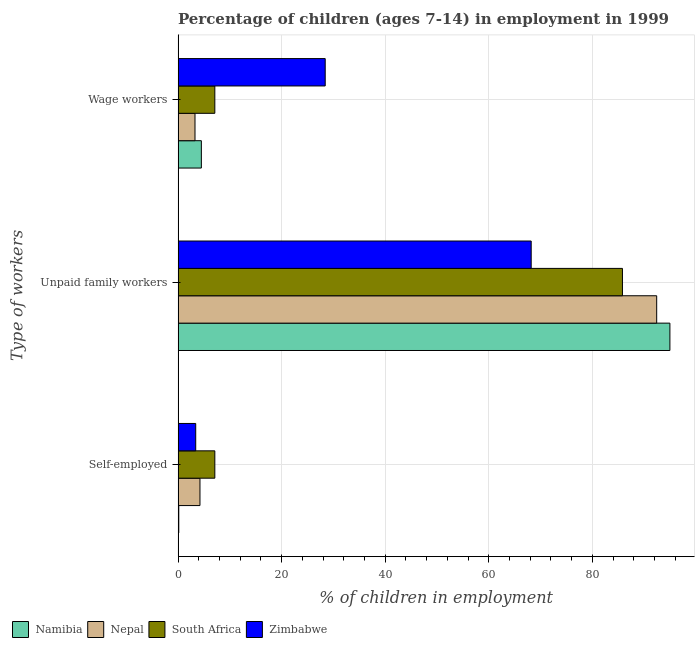How many different coloured bars are there?
Your answer should be compact. 4. Are the number of bars per tick equal to the number of legend labels?
Offer a very short reply. Yes. What is the label of the 1st group of bars from the top?
Make the answer very short. Wage workers. What is the percentage of children employed as unpaid family workers in Nepal?
Keep it short and to the point. 92.41. Across all countries, what is the maximum percentage of children employed as unpaid family workers?
Provide a succinct answer. 94.96. Across all countries, what is the minimum percentage of self employed children?
Keep it short and to the point. 0.14. In which country was the percentage of children employed as unpaid family workers maximum?
Offer a terse response. Namibia. In which country was the percentage of children employed as wage workers minimum?
Make the answer very short. Nepal. What is the total percentage of self employed children in the graph?
Your answer should be compact. 14.88. What is the difference between the percentage of children employed as wage workers in South Africa and that in Namibia?
Provide a short and direct response. 2.6. What is the difference between the percentage of self employed children in Nepal and the percentage of children employed as wage workers in South Africa?
Offer a terse response. -2.87. What is the average percentage of children employed as wage workers per country?
Make the answer very short. 10.82. What is the difference between the percentage of self employed children and percentage of children employed as unpaid family workers in Nepal?
Ensure brevity in your answer.  -88.18. In how many countries, is the percentage of children employed as unpaid family workers greater than 68 %?
Your response must be concise. 4. What is the ratio of the percentage of children employed as wage workers in Nepal to that in Namibia?
Offer a very short reply. 0.73. Is the percentage of children employed as wage workers in Nepal less than that in Namibia?
Give a very brief answer. Yes. Is the difference between the percentage of children employed as wage workers in Nepal and Namibia greater than the difference between the percentage of self employed children in Nepal and Namibia?
Offer a terse response. No. What is the difference between the highest and the second highest percentage of children employed as wage workers?
Make the answer very short. 21.31. What is the difference between the highest and the lowest percentage of children employed as unpaid family workers?
Provide a short and direct response. 26.78. Is the sum of the percentage of children employed as wage workers in Zimbabwe and Namibia greater than the maximum percentage of children employed as unpaid family workers across all countries?
Your answer should be very brief. No. What does the 4th bar from the top in Self-employed represents?
Offer a very short reply. Namibia. What does the 4th bar from the bottom in Self-employed represents?
Provide a succinct answer. Zimbabwe. Are the values on the major ticks of X-axis written in scientific E-notation?
Your answer should be very brief. No. How many legend labels are there?
Provide a succinct answer. 4. What is the title of the graph?
Offer a terse response. Percentage of children (ages 7-14) in employment in 1999. What is the label or title of the X-axis?
Your answer should be compact. % of children in employment. What is the label or title of the Y-axis?
Provide a short and direct response. Type of workers. What is the % of children in employment of Namibia in Self-employed?
Offer a very short reply. 0.14. What is the % of children in employment of Nepal in Self-employed?
Provide a short and direct response. 4.23. What is the % of children in employment in South Africa in Self-employed?
Provide a succinct answer. 7.1. What is the % of children in employment of Zimbabwe in Self-employed?
Offer a very short reply. 3.41. What is the % of children in employment of Namibia in Unpaid family workers?
Keep it short and to the point. 94.96. What is the % of children in employment of Nepal in Unpaid family workers?
Your response must be concise. 92.41. What is the % of children in employment of South Africa in Unpaid family workers?
Provide a short and direct response. 85.8. What is the % of children in employment in Zimbabwe in Unpaid family workers?
Give a very brief answer. 68.18. What is the % of children in employment in Nepal in Wage workers?
Give a very brief answer. 3.27. What is the % of children in employment in Zimbabwe in Wage workers?
Your response must be concise. 28.41. Across all Type of workers, what is the maximum % of children in employment in Namibia?
Make the answer very short. 94.96. Across all Type of workers, what is the maximum % of children in employment of Nepal?
Offer a very short reply. 92.41. Across all Type of workers, what is the maximum % of children in employment of South Africa?
Provide a succinct answer. 85.8. Across all Type of workers, what is the maximum % of children in employment of Zimbabwe?
Your response must be concise. 68.18. Across all Type of workers, what is the minimum % of children in employment in Namibia?
Make the answer very short. 0.14. Across all Type of workers, what is the minimum % of children in employment of Nepal?
Your response must be concise. 3.27. Across all Type of workers, what is the minimum % of children in employment of South Africa?
Keep it short and to the point. 7.1. Across all Type of workers, what is the minimum % of children in employment of Zimbabwe?
Your response must be concise. 3.41. What is the total % of children in employment in Namibia in the graph?
Provide a short and direct response. 99.6. What is the total % of children in employment in Nepal in the graph?
Your response must be concise. 99.91. What is the total % of children in employment in South Africa in the graph?
Offer a very short reply. 100. What is the difference between the % of children in employment in Namibia in Self-employed and that in Unpaid family workers?
Provide a succinct answer. -94.82. What is the difference between the % of children in employment of Nepal in Self-employed and that in Unpaid family workers?
Keep it short and to the point. -88.18. What is the difference between the % of children in employment in South Africa in Self-employed and that in Unpaid family workers?
Your answer should be compact. -78.7. What is the difference between the % of children in employment of Zimbabwe in Self-employed and that in Unpaid family workers?
Your answer should be compact. -64.77. What is the difference between the % of children in employment of Namibia in Self-employed and that in Wage workers?
Keep it short and to the point. -4.36. What is the difference between the % of children in employment in Nepal in Self-employed and that in Wage workers?
Your response must be concise. 0.96. What is the difference between the % of children in employment of South Africa in Self-employed and that in Wage workers?
Your response must be concise. 0. What is the difference between the % of children in employment of Namibia in Unpaid family workers and that in Wage workers?
Ensure brevity in your answer.  90.46. What is the difference between the % of children in employment of Nepal in Unpaid family workers and that in Wage workers?
Offer a terse response. 89.14. What is the difference between the % of children in employment in South Africa in Unpaid family workers and that in Wage workers?
Give a very brief answer. 78.7. What is the difference between the % of children in employment of Zimbabwe in Unpaid family workers and that in Wage workers?
Make the answer very short. 39.77. What is the difference between the % of children in employment in Namibia in Self-employed and the % of children in employment in Nepal in Unpaid family workers?
Make the answer very short. -92.27. What is the difference between the % of children in employment in Namibia in Self-employed and the % of children in employment in South Africa in Unpaid family workers?
Give a very brief answer. -85.66. What is the difference between the % of children in employment of Namibia in Self-employed and the % of children in employment of Zimbabwe in Unpaid family workers?
Offer a terse response. -68.04. What is the difference between the % of children in employment of Nepal in Self-employed and the % of children in employment of South Africa in Unpaid family workers?
Provide a short and direct response. -81.57. What is the difference between the % of children in employment in Nepal in Self-employed and the % of children in employment in Zimbabwe in Unpaid family workers?
Your answer should be very brief. -63.95. What is the difference between the % of children in employment of South Africa in Self-employed and the % of children in employment of Zimbabwe in Unpaid family workers?
Offer a very short reply. -61.08. What is the difference between the % of children in employment of Namibia in Self-employed and the % of children in employment of Nepal in Wage workers?
Make the answer very short. -3.13. What is the difference between the % of children in employment in Namibia in Self-employed and the % of children in employment in South Africa in Wage workers?
Give a very brief answer. -6.96. What is the difference between the % of children in employment in Namibia in Self-employed and the % of children in employment in Zimbabwe in Wage workers?
Provide a succinct answer. -28.27. What is the difference between the % of children in employment of Nepal in Self-employed and the % of children in employment of South Africa in Wage workers?
Make the answer very short. -2.87. What is the difference between the % of children in employment in Nepal in Self-employed and the % of children in employment in Zimbabwe in Wage workers?
Provide a succinct answer. -24.18. What is the difference between the % of children in employment in South Africa in Self-employed and the % of children in employment in Zimbabwe in Wage workers?
Your answer should be compact. -21.31. What is the difference between the % of children in employment in Namibia in Unpaid family workers and the % of children in employment in Nepal in Wage workers?
Ensure brevity in your answer.  91.69. What is the difference between the % of children in employment of Namibia in Unpaid family workers and the % of children in employment of South Africa in Wage workers?
Give a very brief answer. 87.86. What is the difference between the % of children in employment of Namibia in Unpaid family workers and the % of children in employment of Zimbabwe in Wage workers?
Provide a succinct answer. 66.55. What is the difference between the % of children in employment in Nepal in Unpaid family workers and the % of children in employment in South Africa in Wage workers?
Provide a short and direct response. 85.31. What is the difference between the % of children in employment of Nepal in Unpaid family workers and the % of children in employment of Zimbabwe in Wage workers?
Your response must be concise. 64. What is the difference between the % of children in employment of South Africa in Unpaid family workers and the % of children in employment of Zimbabwe in Wage workers?
Your response must be concise. 57.39. What is the average % of children in employment in Namibia per Type of workers?
Provide a short and direct response. 33.2. What is the average % of children in employment of Nepal per Type of workers?
Provide a succinct answer. 33.3. What is the average % of children in employment in South Africa per Type of workers?
Provide a short and direct response. 33.33. What is the average % of children in employment in Zimbabwe per Type of workers?
Your answer should be very brief. 33.33. What is the difference between the % of children in employment in Namibia and % of children in employment in Nepal in Self-employed?
Your answer should be very brief. -4.09. What is the difference between the % of children in employment in Namibia and % of children in employment in South Africa in Self-employed?
Provide a succinct answer. -6.96. What is the difference between the % of children in employment of Namibia and % of children in employment of Zimbabwe in Self-employed?
Offer a very short reply. -3.27. What is the difference between the % of children in employment of Nepal and % of children in employment of South Africa in Self-employed?
Your answer should be compact. -2.87. What is the difference between the % of children in employment of Nepal and % of children in employment of Zimbabwe in Self-employed?
Provide a succinct answer. 0.82. What is the difference between the % of children in employment of South Africa and % of children in employment of Zimbabwe in Self-employed?
Make the answer very short. 3.69. What is the difference between the % of children in employment in Namibia and % of children in employment in Nepal in Unpaid family workers?
Provide a succinct answer. 2.55. What is the difference between the % of children in employment of Namibia and % of children in employment of South Africa in Unpaid family workers?
Keep it short and to the point. 9.16. What is the difference between the % of children in employment of Namibia and % of children in employment of Zimbabwe in Unpaid family workers?
Make the answer very short. 26.78. What is the difference between the % of children in employment in Nepal and % of children in employment in South Africa in Unpaid family workers?
Make the answer very short. 6.61. What is the difference between the % of children in employment of Nepal and % of children in employment of Zimbabwe in Unpaid family workers?
Offer a terse response. 24.23. What is the difference between the % of children in employment in South Africa and % of children in employment in Zimbabwe in Unpaid family workers?
Your answer should be very brief. 17.62. What is the difference between the % of children in employment in Namibia and % of children in employment in Nepal in Wage workers?
Offer a terse response. 1.23. What is the difference between the % of children in employment in Namibia and % of children in employment in Zimbabwe in Wage workers?
Keep it short and to the point. -23.91. What is the difference between the % of children in employment in Nepal and % of children in employment in South Africa in Wage workers?
Keep it short and to the point. -3.83. What is the difference between the % of children in employment of Nepal and % of children in employment of Zimbabwe in Wage workers?
Keep it short and to the point. -25.14. What is the difference between the % of children in employment in South Africa and % of children in employment in Zimbabwe in Wage workers?
Your response must be concise. -21.31. What is the ratio of the % of children in employment of Namibia in Self-employed to that in Unpaid family workers?
Your response must be concise. 0. What is the ratio of the % of children in employment of Nepal in Self-employed to that in Unpaid family workers?
Your answer should be very brief. 0.05. What is the ratio of the % of children in employment of South Africa in Self-employed to that in Unpaid family workers?
Make the answer very short. 0.08. What is the ratio of the % of children in employment of Namibia in Self-employed to that in Wage workers?
Your answer should be compact. 0.03. What is the ratio of the % of children in employment of Nepal in Self-employed to that in Wage workers?
Provide a short and direct response. 1.29. What is the ratio of the % of children in employment in South Africa in Self-employed to that in Wage workers?
Keep it short and to the point. 1. What is the ratio of the % of children in employment in Zimbabwe in Self-employed to that in Wage workers?
Keep it short and to the point. 0.12. What is the ratio of the % of children in employment in Namibia in Unpaid family workers to that in Wage workers?
Make the answer very short. 21.1. What is the ratio of the % of children in employment of Nepal in Unpaid family workers to that in Wage workers?
Offer a very short reply. 28.26. What is the ratio of the % of children in employment of South Africa in Unpaid family workers to that in Wage workers?
Your answer should be compact. 12.08. What is the ratio of the % of children in employment in Zimbabwe in Unpaid family workers to that in Wage workers?
Provide a short and direct response. 2.4. What is the difference between the highest and the second highest % of children in employment in Namibia?
Your answer should be very brief. 90.46. What is the difference between the highest and the second highest % of children in employment in Nepal?
Your answer should be very brief. 88.18. What is the difference between the highest and the second highest % of children in employment in South Africa?
Your response must be concise. 78.7. What is the difference between the highest and the second highest % of children in employment in Zimbabwe?
Keep it short and to the point. 39.77. What is the difference between the highest and the lowest % of children in employment of Namibia?
Your response must be concise. 94.82. What is the difference between the highest and the lowest % of children in employment of Nepal?
Provide a short and direct response. 89.14. What is the difference between the highest and the lowest % of children in employment of South Africa?
Make the answer very short. 78.7. What is the difference between the highest and the lowest % of children in employment of Zimbabwe?
Ensure brevity in your answer.  64.77. 